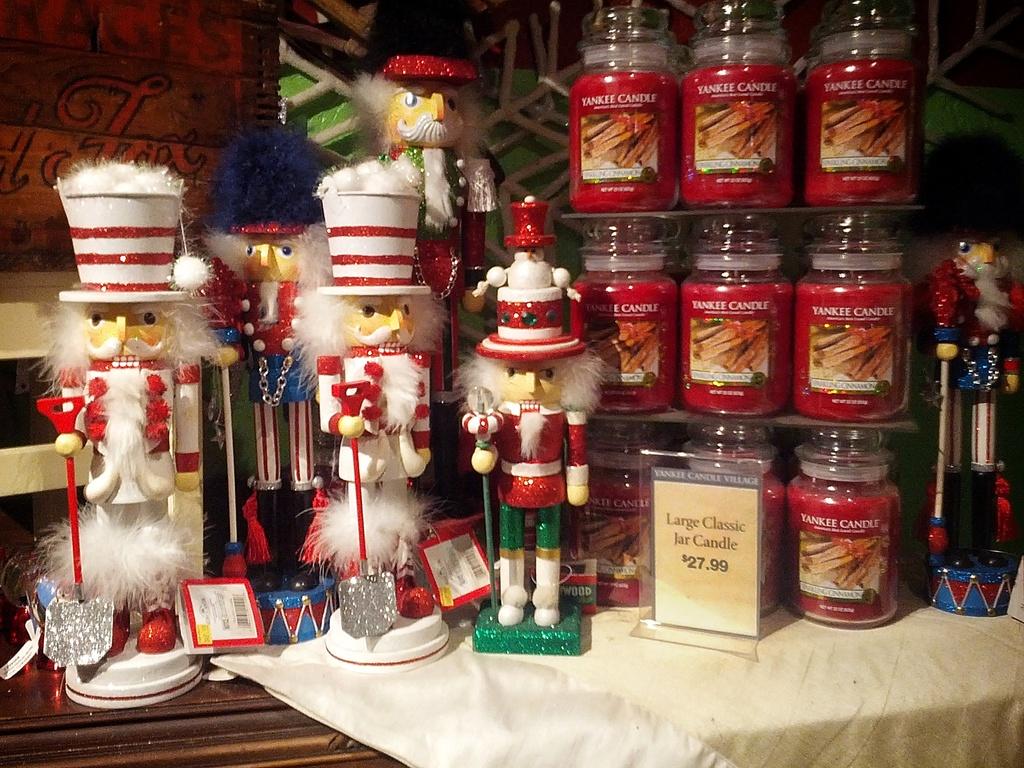How much to the large classic jar candles cost?
Offer a terse response. 27.99. 